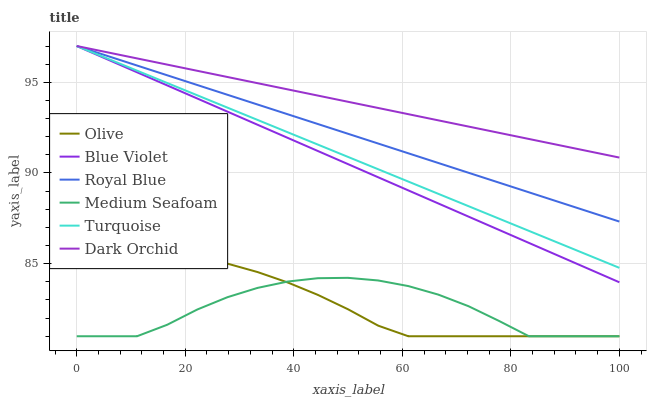Does Medium Seafoam have the minimum area under the curve?
Answer yes or no. Yes. Does Dark Orchid have the maximum area under the curve?
Answer yes or no. Yes. Does Royal Blue have the minimum area under the curve?
Answer yes or no. No. Does Royal Blue have the maximum area under the curve?
Answer yes or no. No. Is Blue Violet the smoothest?
Answer yes or no. Yes. Is Medium Seafoam the roughest?
Answer yes or no. Yes. Is Dark Orchid the smoothest?
Answer yes or no. No. Is Dark Orchid the roughest?
Answer yes or no. No. Does Olive have the lowest value?
Answer yes or no. Yes. Does Royal Blue have the lowest value?
Answer yes or no. No. Does Blue Violet have the highest value?
Answer yes or no. Yes. Does Olive have the highest value?
Answer yes or no. No. Is Olive less than Blue Violet?
Answer yes or no. Yes. Is Royal Blue greater than Olive?
Answer yes or no. Yes. Does Dark Orchid intersect Blue Violet?
Answer yes or no. Yes. Is Dark Orchid less than Blue Violet?
Answer yes or no. No. Is Dark Orchid greater than Blue Violet?
Answer yes or no. No. Does Olive intersect Blue Violet?
Answer yes or no. No. 